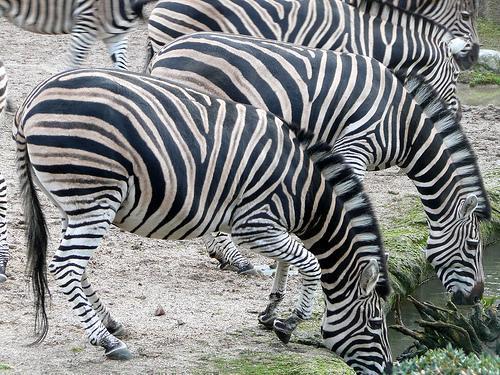How many zebras eating?
Give a very brief answer. 2. 